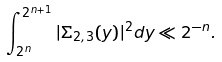<formula> <loc_0><loc_0><loc_500><loc_500>\int _ { 2 ^ { n } } ^ { 2 ^ { n + 1 } } | \Sigma _ { 2 , 3 } ( y ) | ^ { 2 } d y \ll 2 ^ { - n } .</formula> 